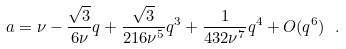Convert formula to latex. <formula><loc_0><loc_0><loc_500><loc_500>a = \nu - \frac { \sqrt { 3 } } { 6 \nu } q + \frac { \sqrt { 3 } } { 2 1 6 \nu ^ { 5 } } q ^ { 3 } + \frac { 1 } { 4 3 2 \nu ^ { 7 } } q ^ { 4 } + O ( q ^ { 6 } ) \ .</formula> 